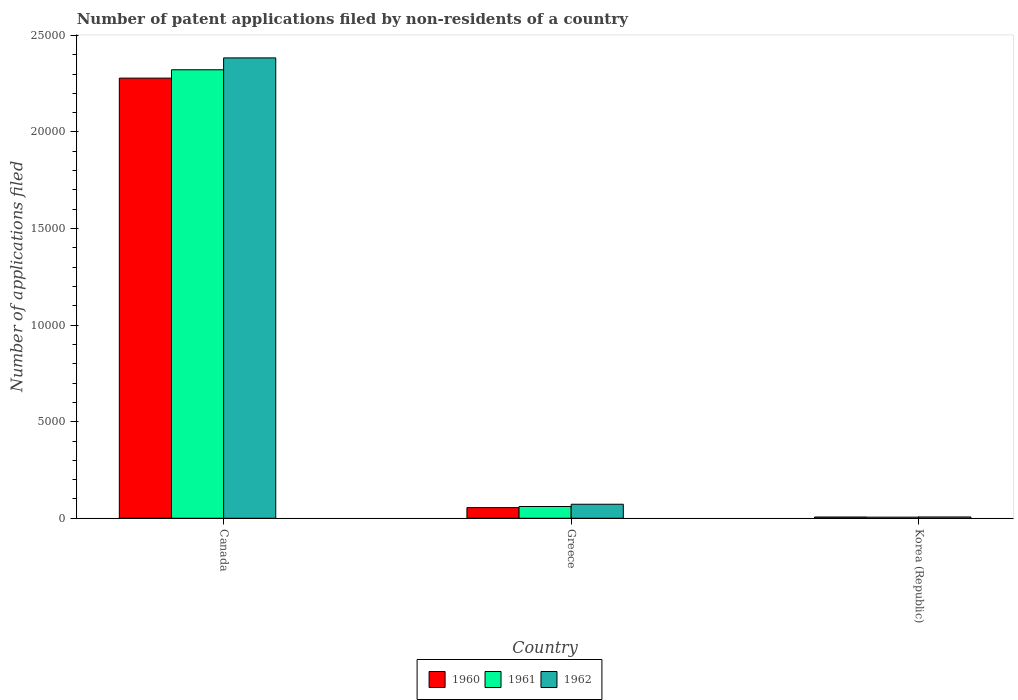How many groups of bars are there?
Your answer should be very brief. 3. Are the number of bars on each tick of the X-axis equal?
Provide a short and direct response. Yes. How many bars are there on the 2nd tick from the left?
Provide a succinct answer. 3. What is the label of the 2nd group of bars from the left?
Keep it short and to the point. Greece. What is the number of applications filed in 1960 in Korea (Republic)?
Offer a very short reply. 66. Across all countries, what is the maximum number of applications filed in 1962?
Your response must be concise. 2.38e+04. Across all countries, what is the minimum number of applications filed in 1961?
Your answer should be compact. 58. In which country was the number of applications filed in 1961 maximum?
Offer a terse response. Canada. What is the total number of applications filed in 1961 in the graph?
Give a very brief answer. 2.39e+04. What is the difference between the number of applications filed in 1960 in Greece and that in Korea (Republic)?
Offer a very short reply. 485. What is the difference between the number of applications filed in 1961 in Greece and the number of applications filed in 1962 in Canada?
Your answer should be very brief. -2.32e+04. What is the average number of applications filed in 1960 per country?
Your answer should be very brief. 7801. What is the difference between the number of applications filed of/in 1962 and number of applications filed of/in 1960 in Korea (Republic)?
Provide a short and direct response. 2. What is the ratio of the number of applications filed in 1961 in Greece to that in Korea (Republic)?
Ensure brevity in your answer.  10.5. Is the number of applications filed in 1961 in Canada less than that in Korea (Republic)?
Provide a succinct answer. No. Is the difference between the number of applications filed in 1962 in Canada and Korea (Republic) greater than the difference between the number of applications filed in 1960 in Canada and Korea (Republic)?
Your answer should be compact. Yes. What is the difference between the highest and the second highest number of applications filed in 1960?
Give a very brief answer. 2.27e+04. What is the difference between the highest and the lowest number of applications filed in 1960?
Your answer should be very brief. 2.27e+04. In how many countries, is the number of applications filed in 1960 greater than the average number of applications filed in 1960 taken over all countries?
Give a very brief answer. 1. Is the sum of the number of applications filed in 1962 in Greece and Korea (Republic) greater than the maximum number of applications filed in 1961 across all countries?
Offer a very short reply. No. What does the 2nd bar from the left in Canada represents?
Offer a very short reply. 1961. What does the 1st bar from the right in Greece represents?
Provide a short and direct response. 1962. How many bars are there?
Give a very brief answer. 9. Are all the bars in the graph horizontal?
Your response must be concise. No. How many countries are there in the graph?
Provide a succinct answer. 3. What is the difference between two consecutive major ticks on the Y-axis?
Make the answer very short. 5000. Are the values on the major ticks of Y-axis written in scientific E-notation?
Offer a terse response. No. Where does the legend appear in the graph?
Your response must be concise. Bottom center. What is the title of the graph?
Provide a succinct answer. Number of patent applications filed by non-residents of a country. What is the label or title of the X-axis?
Make the answer very short. Country. What is the label or title of the Y-axis?
Your response must be concise. Number of applications filed. What is the Number of applications filed of 1960 in Canada?
Give a very brief answer. 2.28e+04. What is the Number of applications filed of 1961 in Canada?
Give a very brief answer. 2.32e+04. What is the Number of applications filed in 1962 in Canada?
Ensure brevity in your answer.  2.38e+04. What is the Number of applications filed in 1960 in Greece?
Ensure brevity in your answer.  551. What is the Number of applications filed in 1961 in Greece?
Offer a very short reply. 609. What is the Number of applications filed of 1962 in Greece?
Make the answer very short. 726. What is the Number of applications filed of 1960 in Korea (Republic)?
Provide a succinct answer. 66. What is the Number of applications filed in 1961 in Korea (Republic)?
Make the answer very short. 58. Across all countries, what is the maximum Number of applications filed in 1960?
Provide a short and direct response. 2.28e+04. Across all countries, what is the maximum Number of applications filed in 1961?
Offer a terse response. 2.32e+04. Across all countries, what is the maximum Number of applications filed of 1962?
Make the answer very short. 2.38e+04. Across all countries, what is the minimum Number of applications filed of 1960?
Ensure brevity in your answer.  66. Across all countries, what is the minimum Number of applications filed of 1962?
Keep it short and to the point. 68. What is the total Number of applications filed of 1960 in the graph?
Keep it short and to the point. 2.34e+04. What is the total Number of applications filed of 1961 in the graph?
Offer a very short reply. 2.39e+04. What is the total Number of applications filed of 1962 in the graph?
Your answer should be compact. 2.46e+04. What is the difference between the Number of applications filed of 1960 in Canada and that in Greece?
Keep it short and to the point. 2.22e+04. What is the difference between the Number of applications filed in 1961 in Canada and that in Greece?
Offer a terse response. 2.26e+04. What is the difference between the Number of applications filed in 1962 in Canada and that in Greece?
Keep it short and to the point. 2.31e+04. What is the difference between the Number of applications filed in 1960 in Canada and that in Korea (Republic)?
Keep it short and to the point. 2.27e+04. What is the difference between the Number of applications filed of 1961 in Canada and that in Korea (Republic)?
Your response must be concise. 2.32e+04. What is the difference between the Number of applications filed in 1962 in Canada and that in Korea (Republic)?
Keep it short and to the point. 2.38e+04. What is the difference between the Number of applications filed in 1960 in Greece and that in Korea (Republic)?
Offer a terse response. 485. What is the difference between the Number of applications filed in 1961 in Greece and that in Korea (Republic)?
Provide a succinct answer. 551. What is the difference between the Number of applications filed of 1962 in Greece and that in Korea (Republic)?
Offer a very short reply. 658. What is the difference between the Number of applications filed of 1960 in Canada and the Number of applications filed of 1961 in Greece?
Provide a succinct answer. 2.22e+04. What is the difference between the Number of applications filed of 1960 in Canada and the Number of applications filed of 1962 in Greece?
Keep it short and to the point. 2.21e+04. What is the difference between the Number of applications filed in 1961 in Canada and the Number of applications filed in 1962 in Greece?
Provide a short and direct response. 2.25e+04. What is the difference between the Number of applications filed of 1960 in Canada and the Number of applications filed of 1961 in Korea (Republic)?
Provide a succinct answer. 2.27e+04. What is the difference between the Number of applications filed in 1960 in Canada and the Number of applications filed in 1962 in Korea (Republic)?
Make the answer very short. 2.27e+04. What is the difference between the Number of applications filed of 1961 in Canada and the Number of applications filed of 1962 in Korea (Republic)?
Your response must be concise. 2.32e+04. What is the difference between the Number of applications filed in 1960 in Greece and the Number of applications filed in 1961 in Korea (Republic)?
Your response must be concise. 493. What is the difference between the Number of applications filed in 1960 in Greece and the Number of applications filed in 1962 in Korea (Republic)?
Offer a very short reply. 483. What is the difference between the Number of applications filed in 1961 in Greece and the Number of applications filed in 1962 in Korea (Republic)?
Keep it short and to the point. 541. What is the average Number of applications filed in 1960 per country?
Provide a succinct answer. 7801. What is the average Number of applications filed of 1961 per country?
Your response must be concise. 7962. What is the average Number of applications filed of 1962 per country?
Give a very brief answer. 8209.33. What is the difference between the Number of applications filed of 1960 and Number of applications filed of 1961 in Canada?
Provide a succinct answer. -433. What is the difference between the Number of applications filed of 1960 and Number of applications filed of 1962 in Canada?
Ensure brevity in your answer.  -1048. What is the difference between the Number of applications filed of 1961 and Number of applications filed of 1962 in Canada?
Offer a terse response. -615. What is the difference between the Number of applications filed of 1960 and Number of applications filed of 1961 in Greece?
Your answer should be compact. -58. What is the difference between the Number of applications filed in 1960 and Number of applications filed in 1962 in Greece?
Your answer should be compact. -175. What is the difference between the Number of applications filed in 1961 and Number of applications filed in 1962 in Greece?
Your response must be concise. -117. What is the difference between the Number of applications filed in 1961 and Number of applications filed in 1962 in Korea (Republic)?
Offer a very short reply. -10. What is the ratio of the Number of applications filed in 1960 in Canada to that in Greece?
Your answer should be compact. 41.35. What is the ratio of the Number of applications filed in 1961 in Canada to that in Greece?
Offer a very short reply. 38.13. What is the ratio of the Number of applications filed in 1962 in Canada to that in Greece?
Keep it short and to the point. 32.83. What is the ratio of the Number of applications filed of 1960 in Canada to that in Korea (Republic)?
Provide a short and direct response. 345.24. What is the ratio of the Number of applications filed in 1961 in Canada to that in Korea (Republic)?
Offer a terse response. 400.33. What is the ratio of the Number of applications filed in 1962 in Canada to that in Korea (Republic)?
Keep it short and to the point. 350.5. What is the ratio of the Number of applications filed in 1960 in Greece to that in Korea (Republic)?
Keep it short and to the point. 8.35. What is the ratio of the Number of applications filed in 1961 in Greece to that in Korea (Republic)?
Offer a very short reply. 10.5. What is the ratio of the Number of applications filed of 1962 in Greece to that in Korea (Republic)?
Provide a short and direct response. 10.68. What is the difference between the highest and the second highest Number of applications filed of 1960?
Provide a succinct answer. 2.22e+04. What is the difference between the highest and the second highest Number of applications filed of 1961?
Ensure brevity in your answer.  2.26e+04. What is the difference between the highest and the second highest Number of applications filed in 1962?
Offer a terse response. 2.31e+04. What is the difference between the highest and the lowest Number of applications filed in 1960?
Your answer should be very brief. 2.27e+04. What is the difference between the highest and the lowest Number of applications filed of 1961?
Your answer should be very brief. 2.32e+04. What is the difference between the highest and the lowest Number of applications filed in 1962?
Provide a succinct answer. 2.38e+04. 